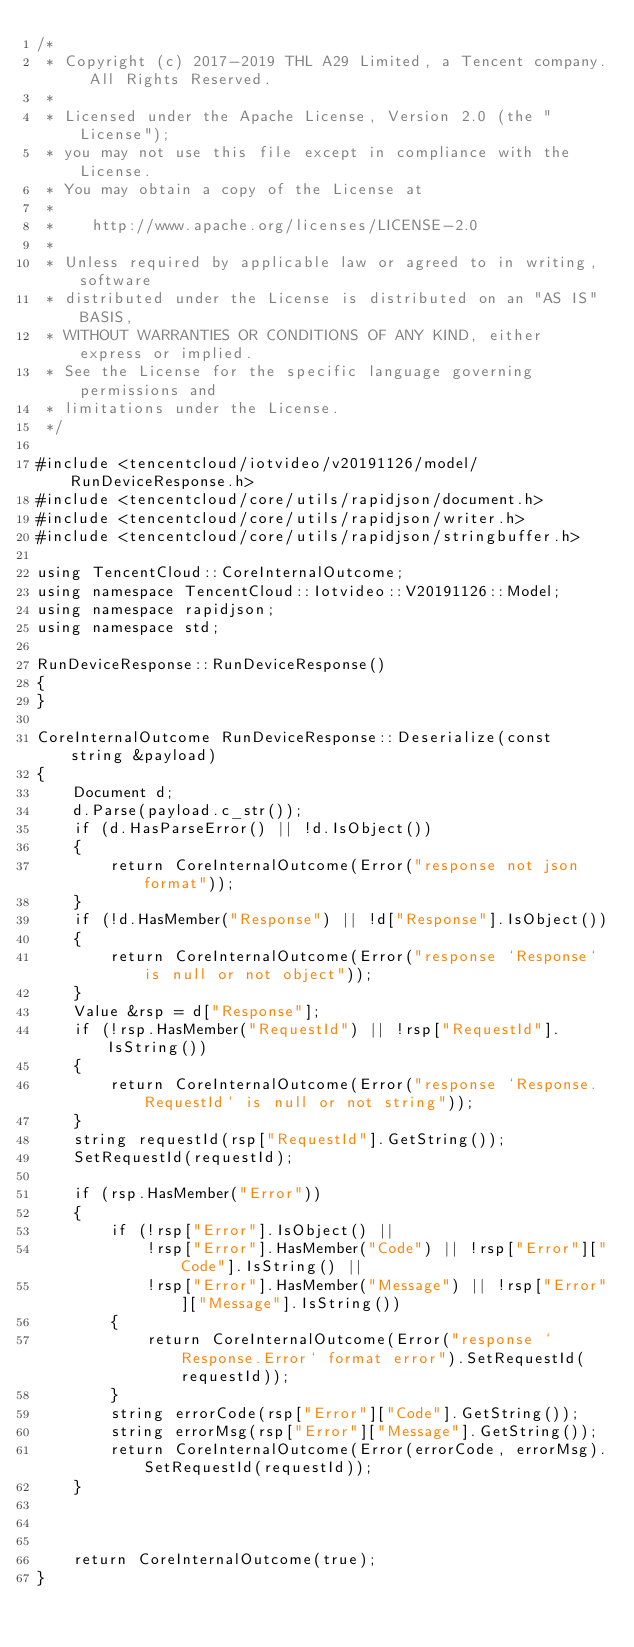<code> <loc_0><loc_0><loc_500><loc_500><_C++_>/*
 * Copyright (c) 2017-2019 THL A29 Limited, a Tencent company. All Rights Reserved.
 *
 * Licensed under the Apache License, Version 2.0 (the "License");
 * you may not use this file except in compliance with the License.
 * You may obtain a copy of the License at
 *
 *    http://www.apache.org/licenses/LICENSE-2.0
 *
 * Unless required by applicable law or agreed to in writing, software
 * distributed under the License is distributed on an "AS IS" BASIS,
 * WITHOUT WARRANTIES OR CONDITIONS OF ANY KIND, either express or implied.
 * See the License for the specific language governing permissions and
 * limitations under the License.
 */

#include <tencentcloud/iotvideo/v20191126/model/RunDeviceResponse.h>
#include <tencentcloud/core/utils/rapidjson/document.h>
#include <tencentcloud/core/utils/rapidjson/writer.h>
#include <tencentcloud/core/utils/rapidjson/stringbuffer.h>

using TencentCloud::CoreInternalOutcome;
using namespace TencentCloud::Iotvideo::V20191126::Model;
using namespace rapidjson;
using namespace std;

RunDeviceResponse::RunDeviceResponse()
{
}

CoreInternalOutcome RunDeviceResponse::Deserialize(const string &payload)
{
    Document d;
    d.Parse(payload.c_str());
    if (d.HasParseError() || !d.IsObject())
    {
        return CoreInternalOutcome(Error("response not json format"));
    }
    if (!d.HasMember("Response") || !d["Response"].IsObject())
    {
        return CoreInternalOutcome(Error("response `Response` is null or not object"));
    }
    Value &rsp = d["Response"];
    if (!rsp.HasMember("RequestId") || !rsp["RequestId"].IsString())
    {
        return CoreInternalOutcome(Error("response `Response.RequestId` is null or not string"));
    }
    string requestId(rsp["RequestId"].GetString());
    SetRequestId(requestId);

    if (rsp.HasMember("Error"))
    {
        if (!rsp["Error"].IsObject() ||
            !rsp["Error"].HasMember("Code") || !rsp["Error"]["Code"].IsString() ||
            !rsp["Error"].HasMember("Message") || !rsp["Error"]["Message"].IsString())
        {
            return CoreInternalOutcome(Error("response `Response.Error` format error").SetRequestId(requestId));
        }
        string errorCode(rsp["Error"]["Code"].GetString());
        string errorMsg(rsp["Error"]["Message"].GetString());
        return CoreInternalOutcome(Error(errorCode, errorMsg).SetRequestId(requestId));
    }



    return CoreInternalOutcome(true);
}



</code> 